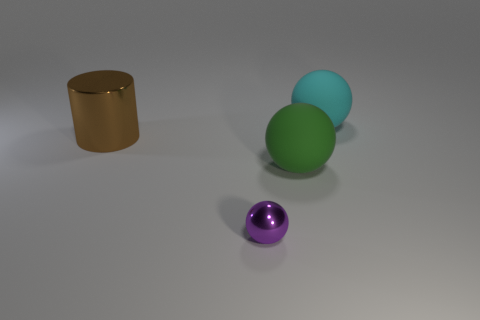Are there any other objects of the same shape as the green thing?
Your answer should be compact. Yes. There is a thing that is left of the large green matte sphere and behind the small purple sphere; what is its shape?
Your answer should be very brief. Cylinder. Is the big cylinder made of the same material as the thing that is behind the large brown cylinder?
Provide a succinct answer. No. Are there any purple metal objects behind the big green rubber ball?
Your answer should be compact. No. How many things are large green objects or big things that are in front of the brown thing?
Your answer should be very brief. 1. There is a metallic thing in front of the metal object to the left of the tiny sphere; what color is it?
Provide a succinct answer. Purple. How many other things are there of the same material as the large green ball?
Your answer should be compact. 1. How many matte objects are large brown things or small purple balls?
Keep it short and to the point. 0. What is the color of the other small thing that is the same shape as the cyan object?
Offer a very short reply. Purple. What number of objects are either small purple shiny spheres or purple matte blocks?
Offer a very short reply. 1. 